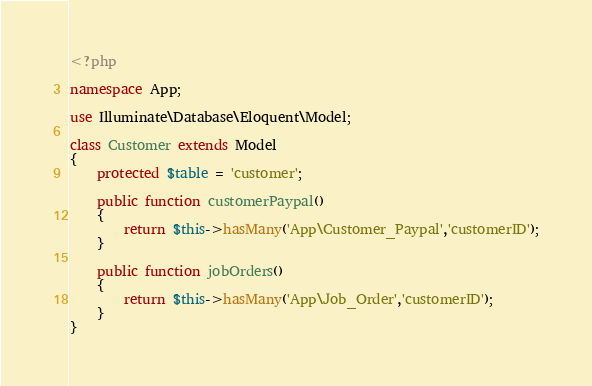Convert code to text. <code><loc_0><loc_0><loc_500><loc_500><_PHP_><?php

namespace App;

use Illuminate\Database\Eloquent\Model;

class Customer extends Model
{
    protected $table = 'customer';
    
    public function customerPaypal()
    {
        return $this->hasMany('App\Customer_Paypal','customerID');
    }
    
    public function jobOrders()
    {
        return $this->hasMany('App\Job_Order','customerID');
    }
}
</code> 